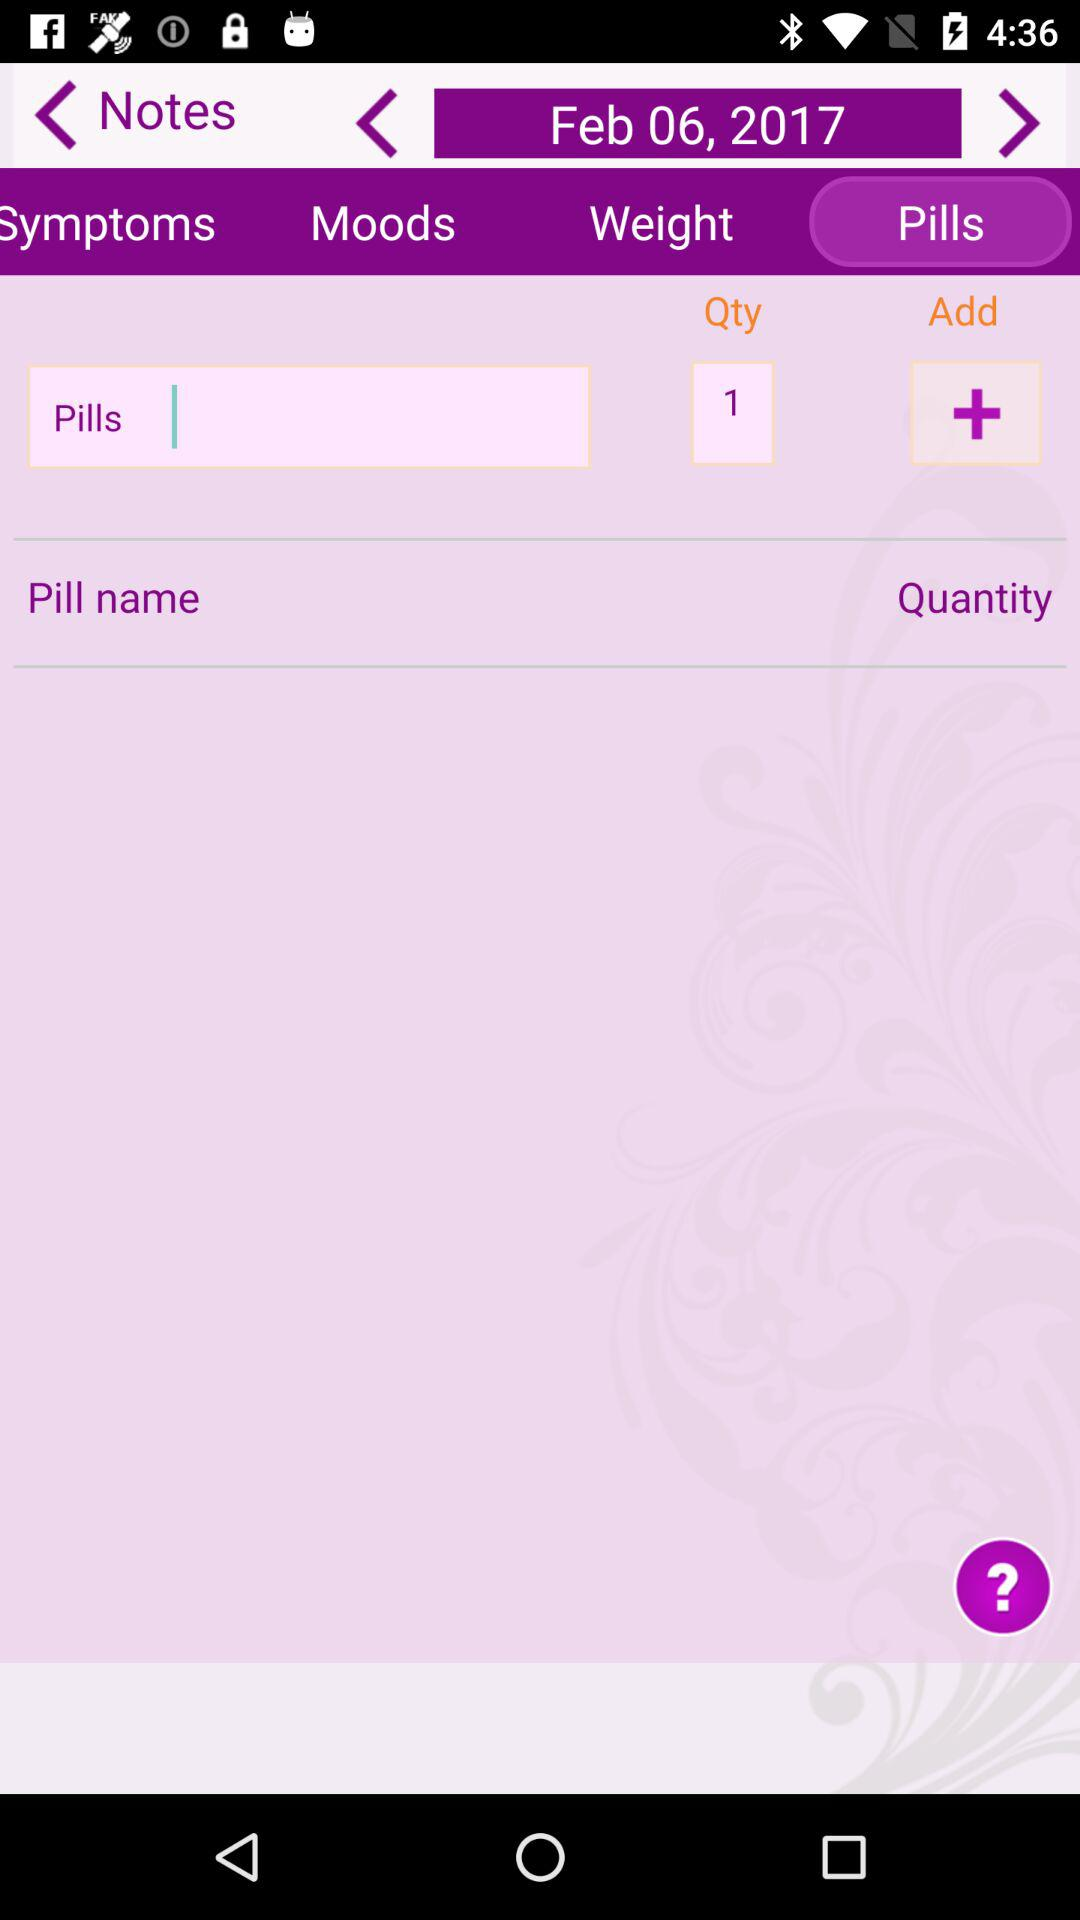What is the selected date? The selected date is February 6, 2017. 